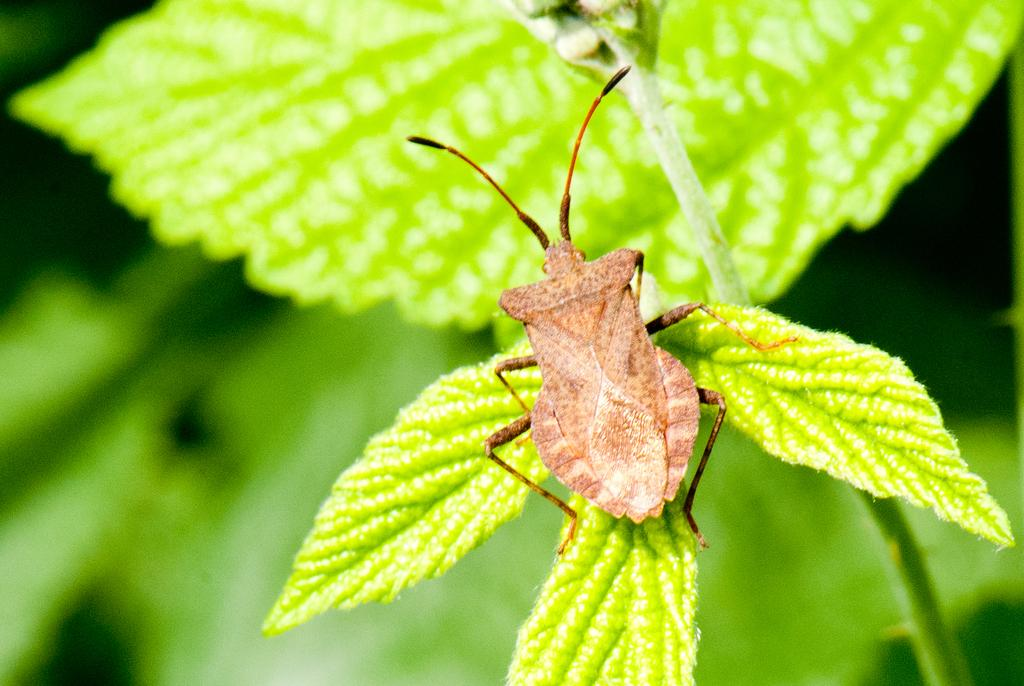What type of creature is in the image? There is a brown insect in the image. Where is the insect located? The insect is on green leaves. What color is the background of the image? The background of the image is green. What is the writer doing in the image? There is no writer present in the image; it features a brown insect on green leaves. Can you see a giraffe in the image? There is no giraffe present in the image; it features a brown insect on green leaves. 